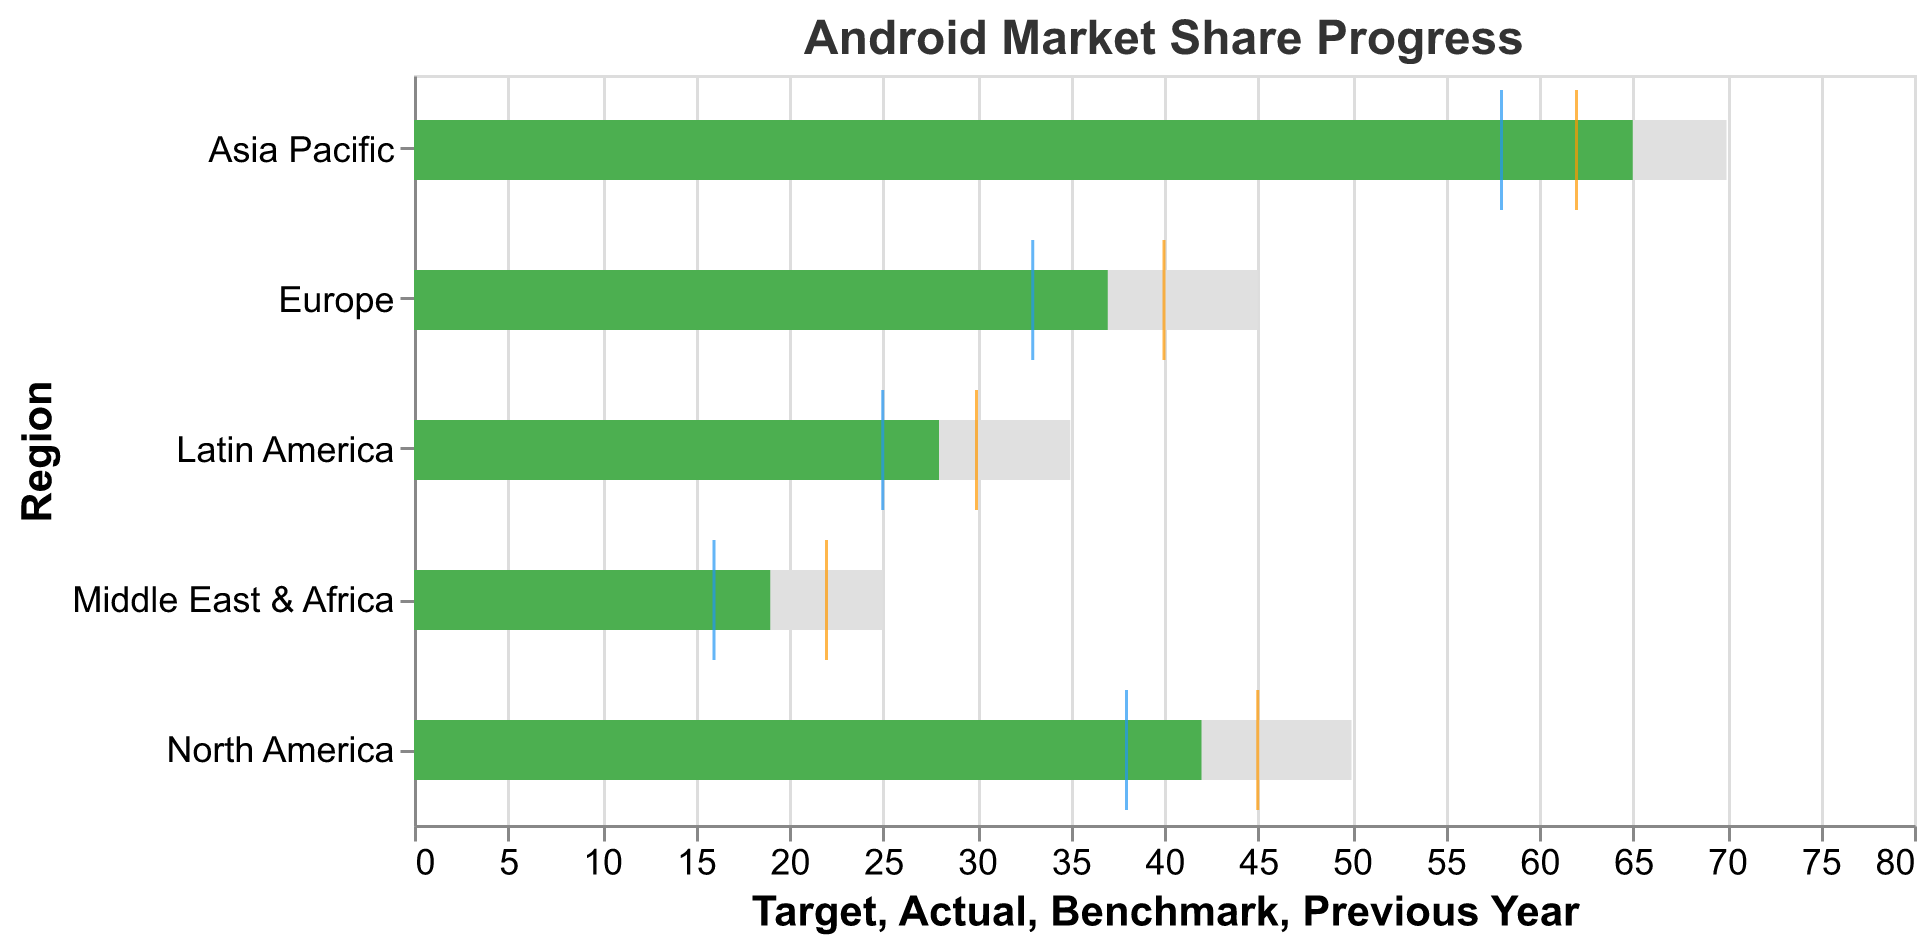What's the title of the chart? The title of the chart describes what the data is about, which is "Android Market Share Progress." This can be found at the top of the chart.
Answer: Android Market Share Progress Which region has the highest actual market share? The region with a bar that extends the furthest in the "Actual" market share area of the chart represents the highest actual market share. In this case, it is the Asia Pacific with an actual market share of 65.
Answer: Asia Pacific What's the difference between the target and actual market share for North America? Subtract the actual market share from the target market share for North America. Target: 50, Actual: 42, so the difference is 50 - 42 = 8.
Answer: 8 Which region fell the shortest in achieving its target? The region where the difference between the target and the actual market share is the largest represents the shortest fall. For Middle East & Africa, the difference is 25 - 19 = 6, which is the largest gap.
Answer: Middle East & Africa How does the benchmark compare to the actual market share for Europe? Compare the benchmark value with the actual market share value for Europe. Benchmark: 40, Actual: 37, so the benchmark is higher.
Answer: The benchmark is higher What's the average of the actual market shares across all regions? Add all the actual market share values and divide by the number of regions. (42 + 37 + 65 + 28 + 19) / 5 = 191 / 5 = 38.2
Answer: 38.2 Which region showed the most improvement compared to the previous year? Calculate the difference between the actual market share and the previous year for each region, then find the largest difference. Asia Pacific: 65 - 58 = 7, which is the highest improvement.
Answer: Asia Pacific How many regions have their benchmark higher than the actual market share? Identify the regions where the benchmark value is higher than the actual market share and count them. Europe (40 > 37), Middle East & Africa (22 > 19) are the regions fitting this criteria.
Answer: 2 What is the average target market share across all regions? Sum all the target market share values and divide by the number of regions. (50 + 45 + 70 + 35 + 25) / 5 = 225 / 5 = 45
Answer: 45 